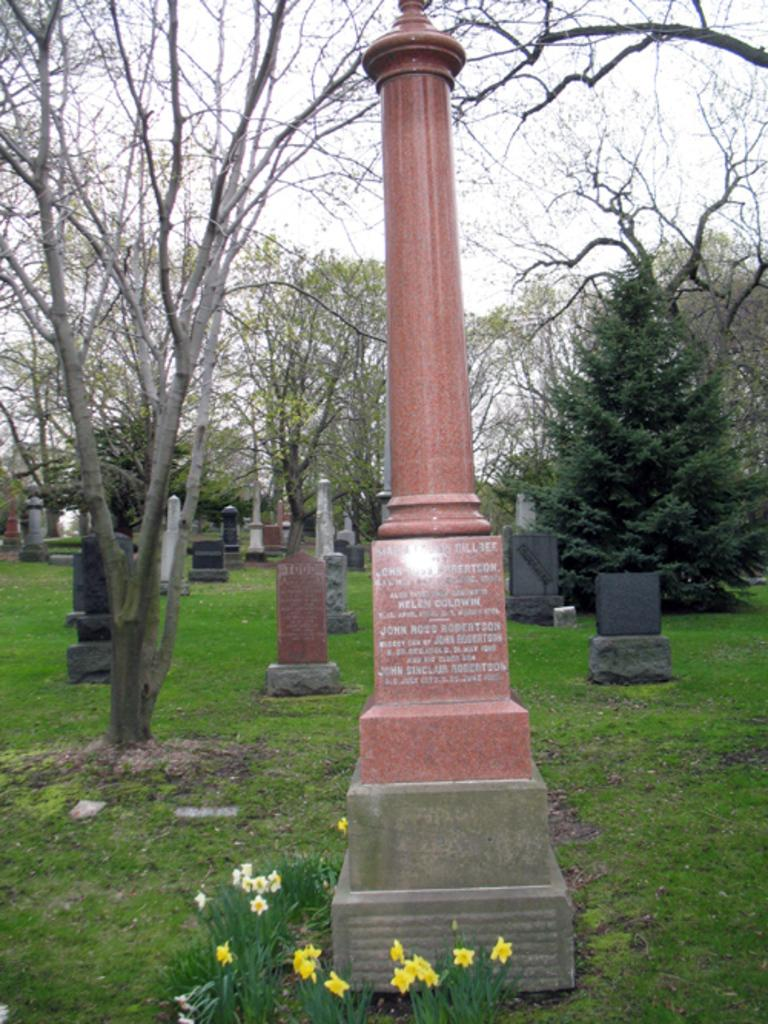Where was the image taken? The image was taken in a cemetery. What can be seen in the cemetery? There are gravestones, plants, flowers, and trees in the image. What is the weather like in the image? The sky is cloudy in the image. What type of ornament is hanging on the gravestone in the image? There is no ornament hanging on the gravestone in the image. How many people are taking a bath in the image? There are no people taking a bath in the image. 